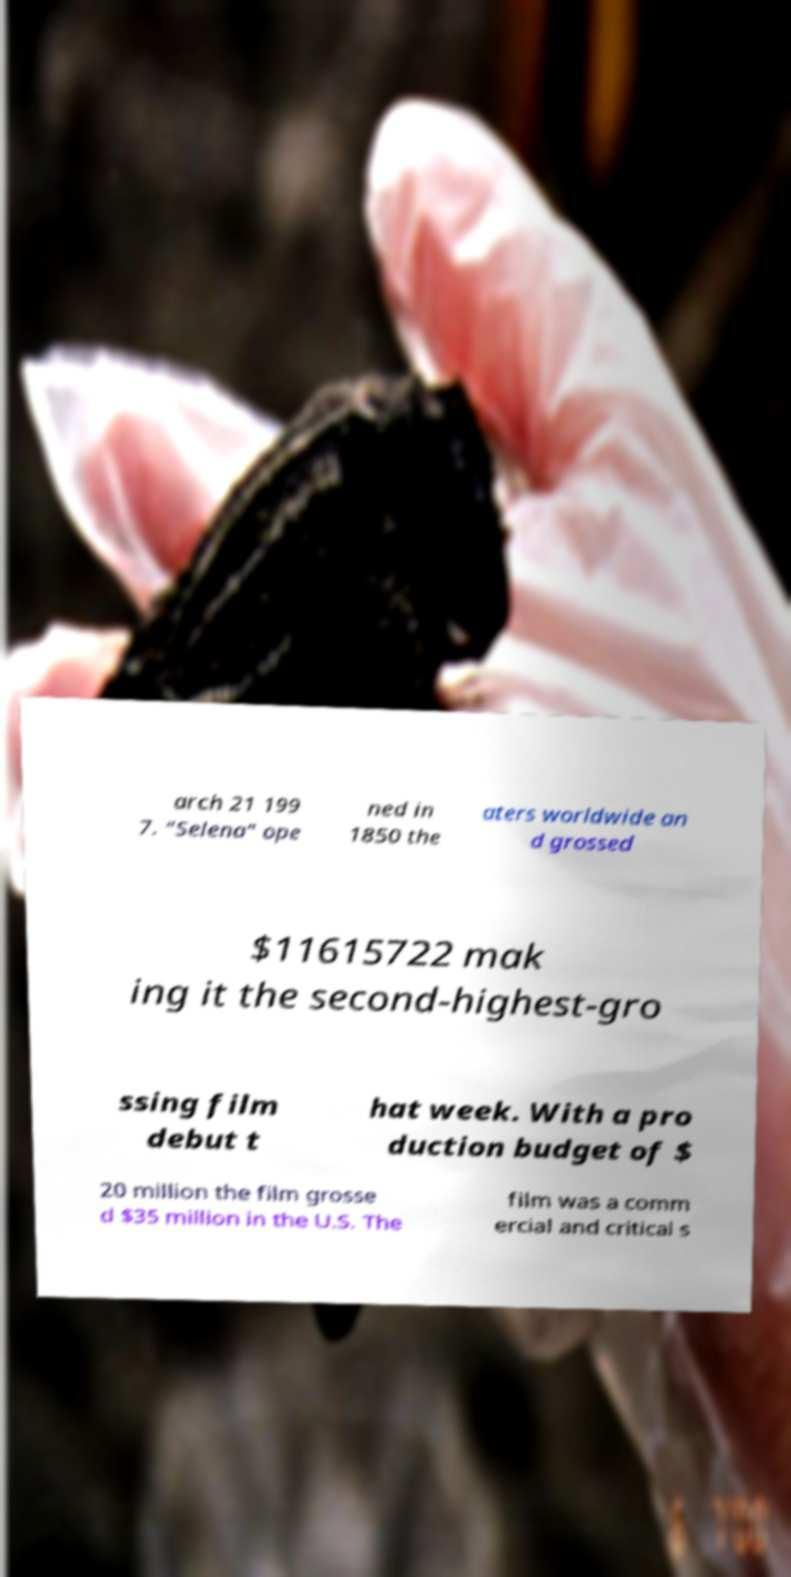Please identify and transcribe the text found in this image. arch 21 199 7. "Selena" ope ned in 1850 the aters worldwide an d grossed $11615722 mak ing it the second-highest-gro ssing film debut t hat week. With a pro duction budget of $ 20 million the film grosse d $35 million in the U.S. The film was a comm ercial and critical s 